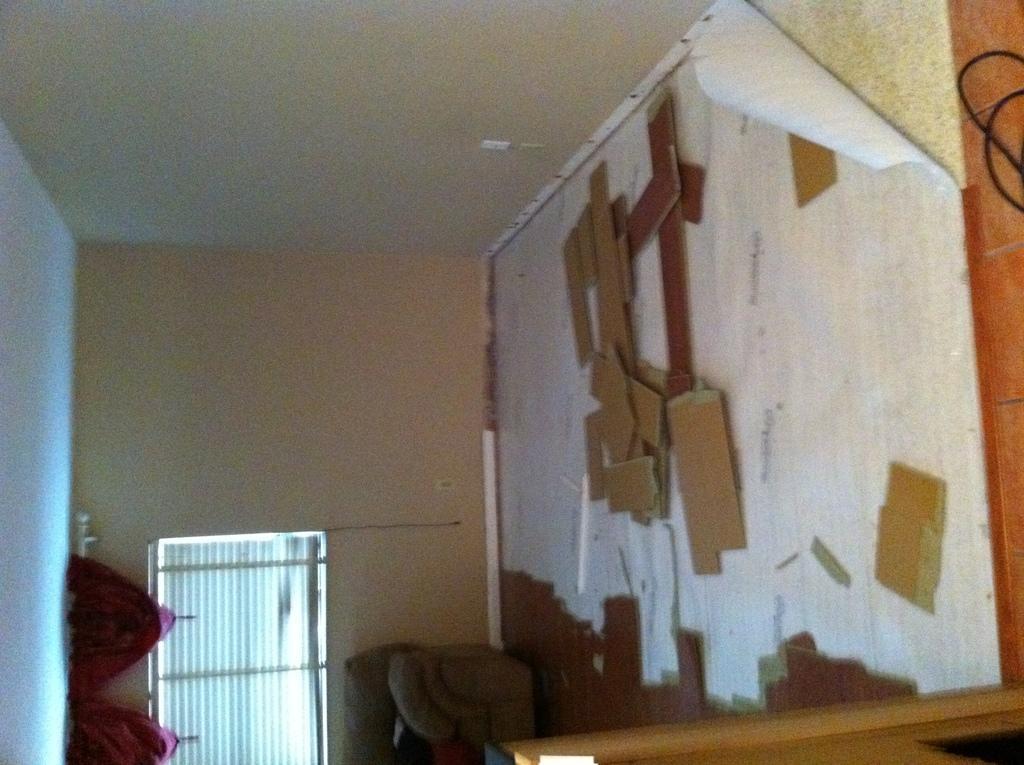In one or two sentences, can you explain what this image depicts? In this image I can see there is a door and on the left side there some wooden stick on the wall. 